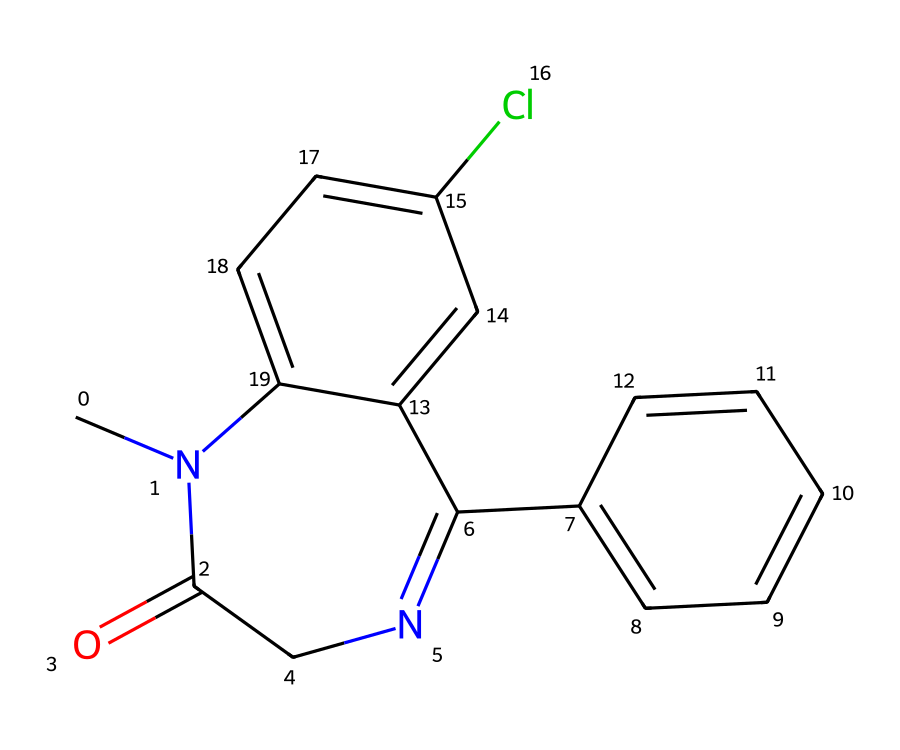What is the primary functional group in this chemical? The chemical contains an amide group (CN1C(=O)CN), characterized by the carbonyl (C=O) adjacent to a nitrogen atom (N). This identifies it as having properties related to amides.
Answer: amide How many carbon atoms are present in the structure? By counting the carbon atoms in the SMILES representation (C, c, and the carbonyl), there are 15 carbon atoms total in the structure.
Answer: 15 What type of ring structure is observed in this chemical? The chemical contains multiple ring structures; specifically, it has fused rings which are present in benzodiazepines, where two cyclic compounds share two carbon atoms.
Answer: fused Which atom in the structure is responsible for potential interaction with GABA receptors? The nitrogen atoms contribute to the binding properties of benzodiazepines at GABA receptors, influencing their pharmacological action against anxiety.
Answer: nitrogen What is the impact of the chlorine substituent on the aromatic ring? The chlorine substituent (Cl) alters the electronic properties of the ring, often enhancing the biological activity of the compound by modulating its lipophilicity and polarizability.
Answer: enhances activity 